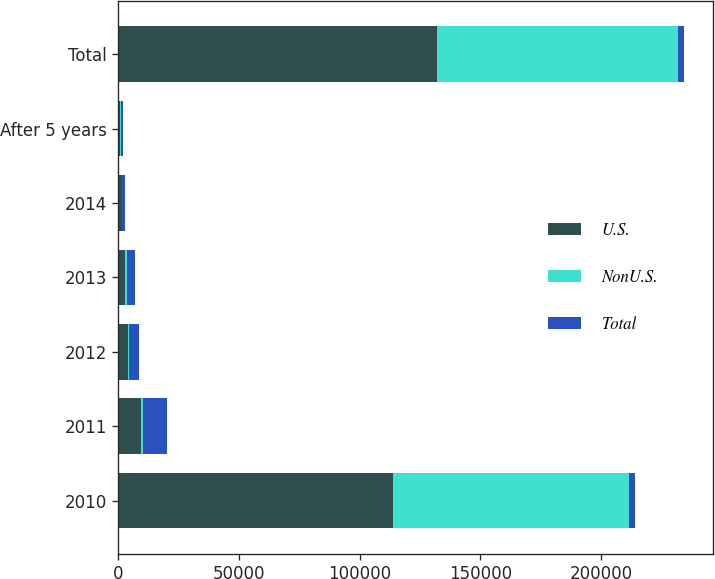Convert chart. <chart><loc_0><loc_0><loc_500><loc_500><stacked_bar_chart><ecel><fcel>2010<fcel>2011<fcel>2012<fcel>2013<fcel>2014<fcel>After 5 years<fcel>Total<nl><fcel>U.S.<fcel>113912<fcel>9489<fcel>3851<fcel>2783<fcel>1321<fcel>671<fcel>132027<nl><fcel>NonU.S.<fcel>97465<fcel>654<fcel>485<fcel>634<fcel>127<fcel>267<fcel>99632<nl><fcel>Total<fcel>2783<fcel>10143<fcel>4336<fcel>3417<fcel>1448<fcel>938<fcel>2783<nl></chart> 